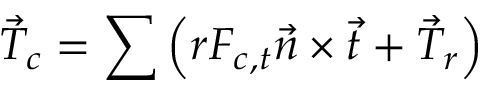Convert formula to latex. <formula><loc_0><loc_0><loc_500><loc_500>\vec { T } _ { c } = \sum \left ( r F _ { c , t } \vec { n } \times \vec { t } + \vec { T } _ { r } \right )</formula> 